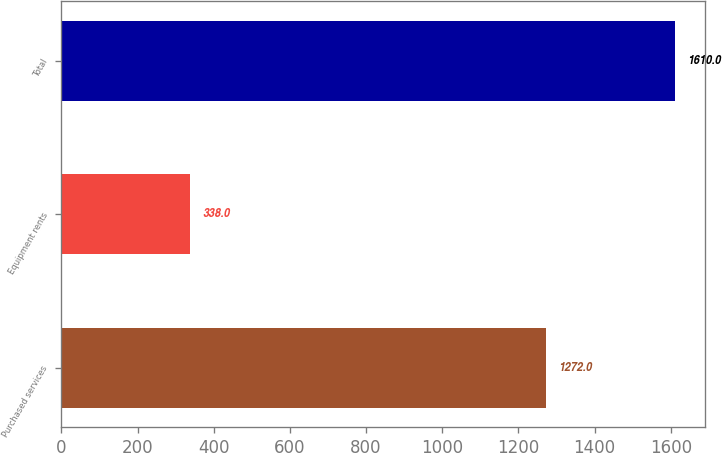Convert chart to OTSL. <chart><loc_0><loc_0><loc_500><loc_500><bar_chart><fcel>Purchased services<fcel>Equipment rents<fcel>Total<nl><fcel>1272<fcel>338<fcel>1610<nl></chart> 